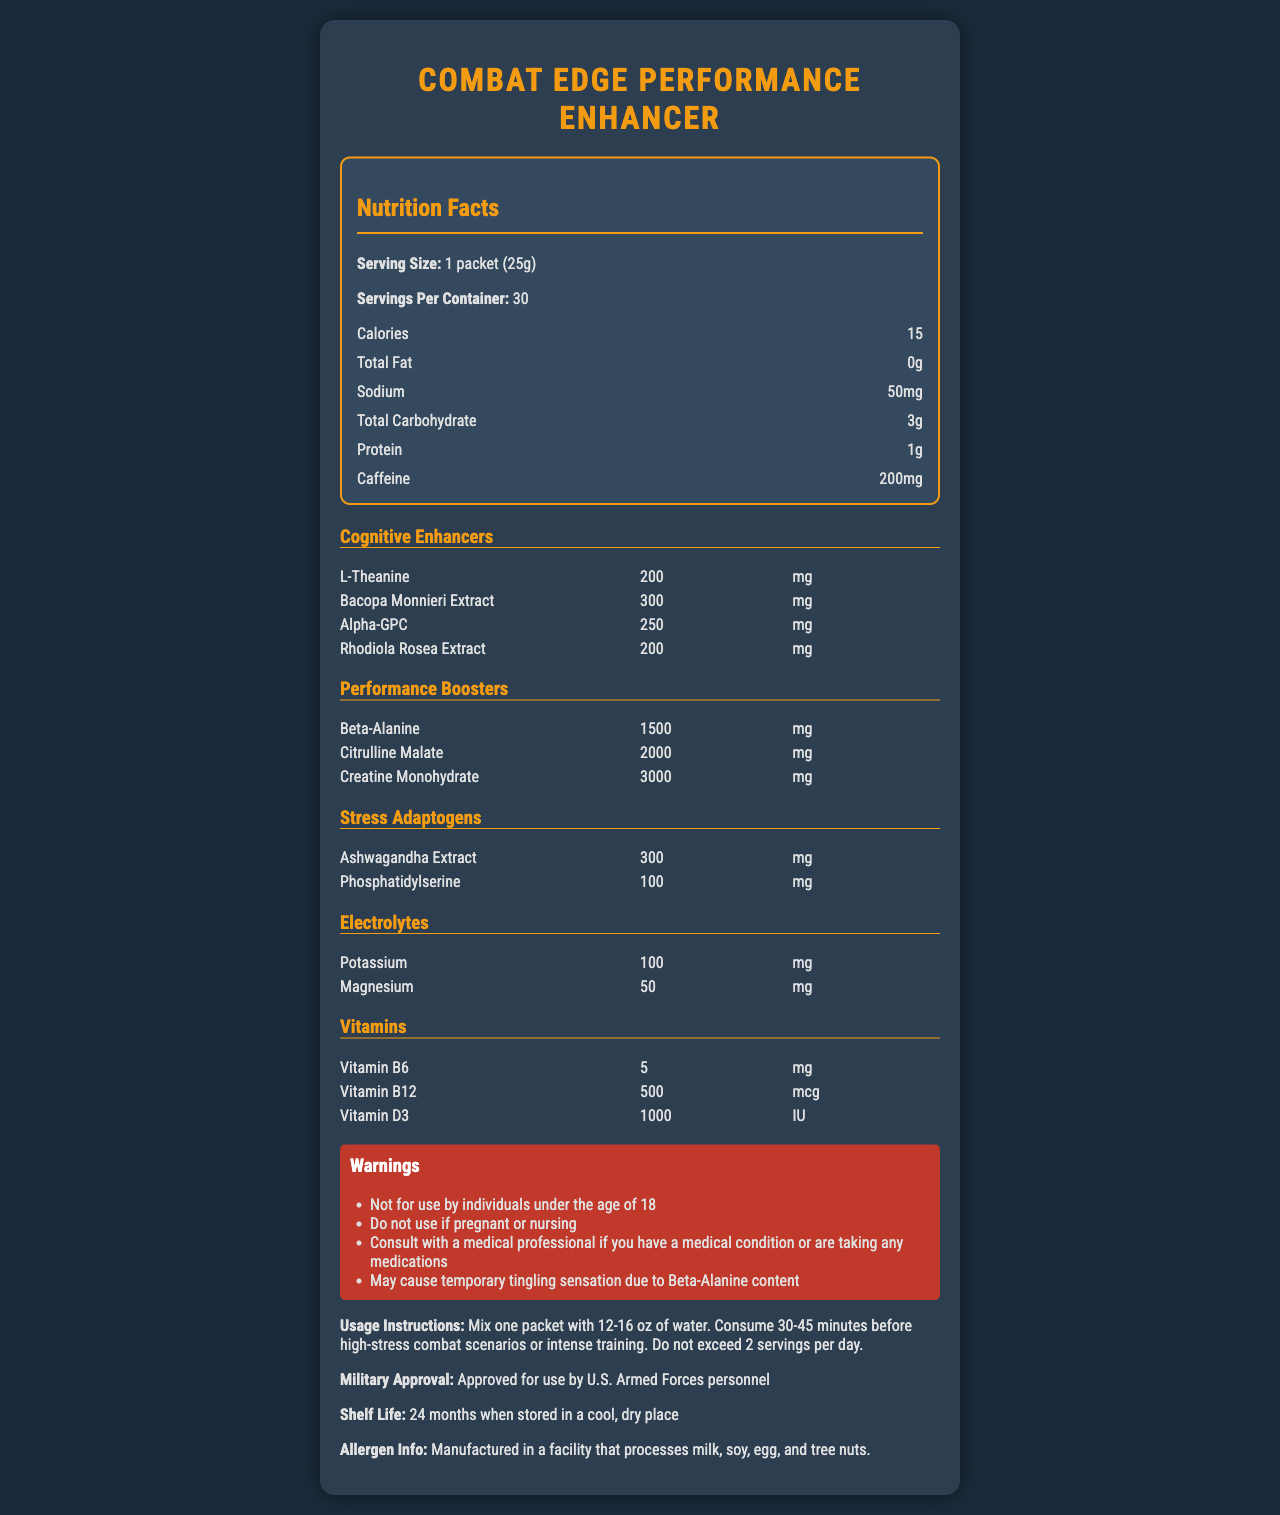how many servings are in a container? The document states that there are 30 servings per container.
Answer: 30 what is the sodium content per serving? The document lists the sodium content as 50 mg per serving.
Answer: 50 mg how much caffeine does one serving contain? According to the document, one serving contains 200 mg of caffeine.
Answer: 200 mg name two cognitive enhancers included in the supplement and their amounts The document lists L-Theanine at 200 mg and Bacopa Monnieri Extract at 300 mg as cognitive enhancers.
Answer: L-Theanine: 200 mg, Bacopa Monnieri Extract: 300 mg list the vitamins included in the supplement and their amounts The document shows Vitamin B6, B12, and D3 with respective amounts of 5 mg, 500 mcg, and 1000 IU.
Answer: Vitamin B6: 5 mg, Vitamin B12: 500 mcg, Vitamin D3: 1000 IU which of the following ingredients is NOT included in the stress adaptogens? A. Ashwagandha Extract B. Phosphatidylserine C. Rhodiola Rosea D. Beta-Alanine The document lists Ashwagandha Extract and Phosphatidylserine as stress adaptogens, but Beta-Alanine is listed under performance boosters.
Answer: D. Beta-Alanine what should you do before using this supplement if you have a medical condition? The document advises consulting with a medical professional if you have a medical condition.
Answer: Consult with a medical professional is the product approved for use by the U.S. Armed Forces personnel? (Yes/No) The document states that the product is approved for use by U.S. Armed Forces personnel.
Answer: Yes true or false: The supplement contains electrolytes. The document lists Potassium and Magnesium as electrolytes included in the supplement.
Answer: True summarize the main purpose and contents of the document The document is intended to inform potential users, especially military personnel, about the components and benefits of the supplement, usage guidelines, and safety information.
Answer: The document provides detailed information about the Combat Edge Performance Enhancer, including its serving size, nutritional facts, and list of cognitive enhancers, performance boosters, stress adaptogens, electrolytes, and vitamins. It also includes usage instructions, warnings, and military approval information. how much Beta-Alanine is included in one serving? The document details that one serving contains 1500 mg of Beta-Alanine.
Answer: 1500 mg what is the recommended usage for this supplement? The document provides specific usage instructions: mix one packet with 12-16 oz of water, consume 30-45 minutes before high-stress combat scenarios or intense training, and do not exceed 2 servings per day.
Answer: Mix one packet with 12-16 oz of water. Consume 30-45 minutes before high-stress combat scenarios or intense training. Do not exceed 2 servings per day. cannot be determined based on the document: what is the manufacturing date of the supplement? The document does not provide information on the manufacturing date of the supplement.
Answer: Cannot be determined 